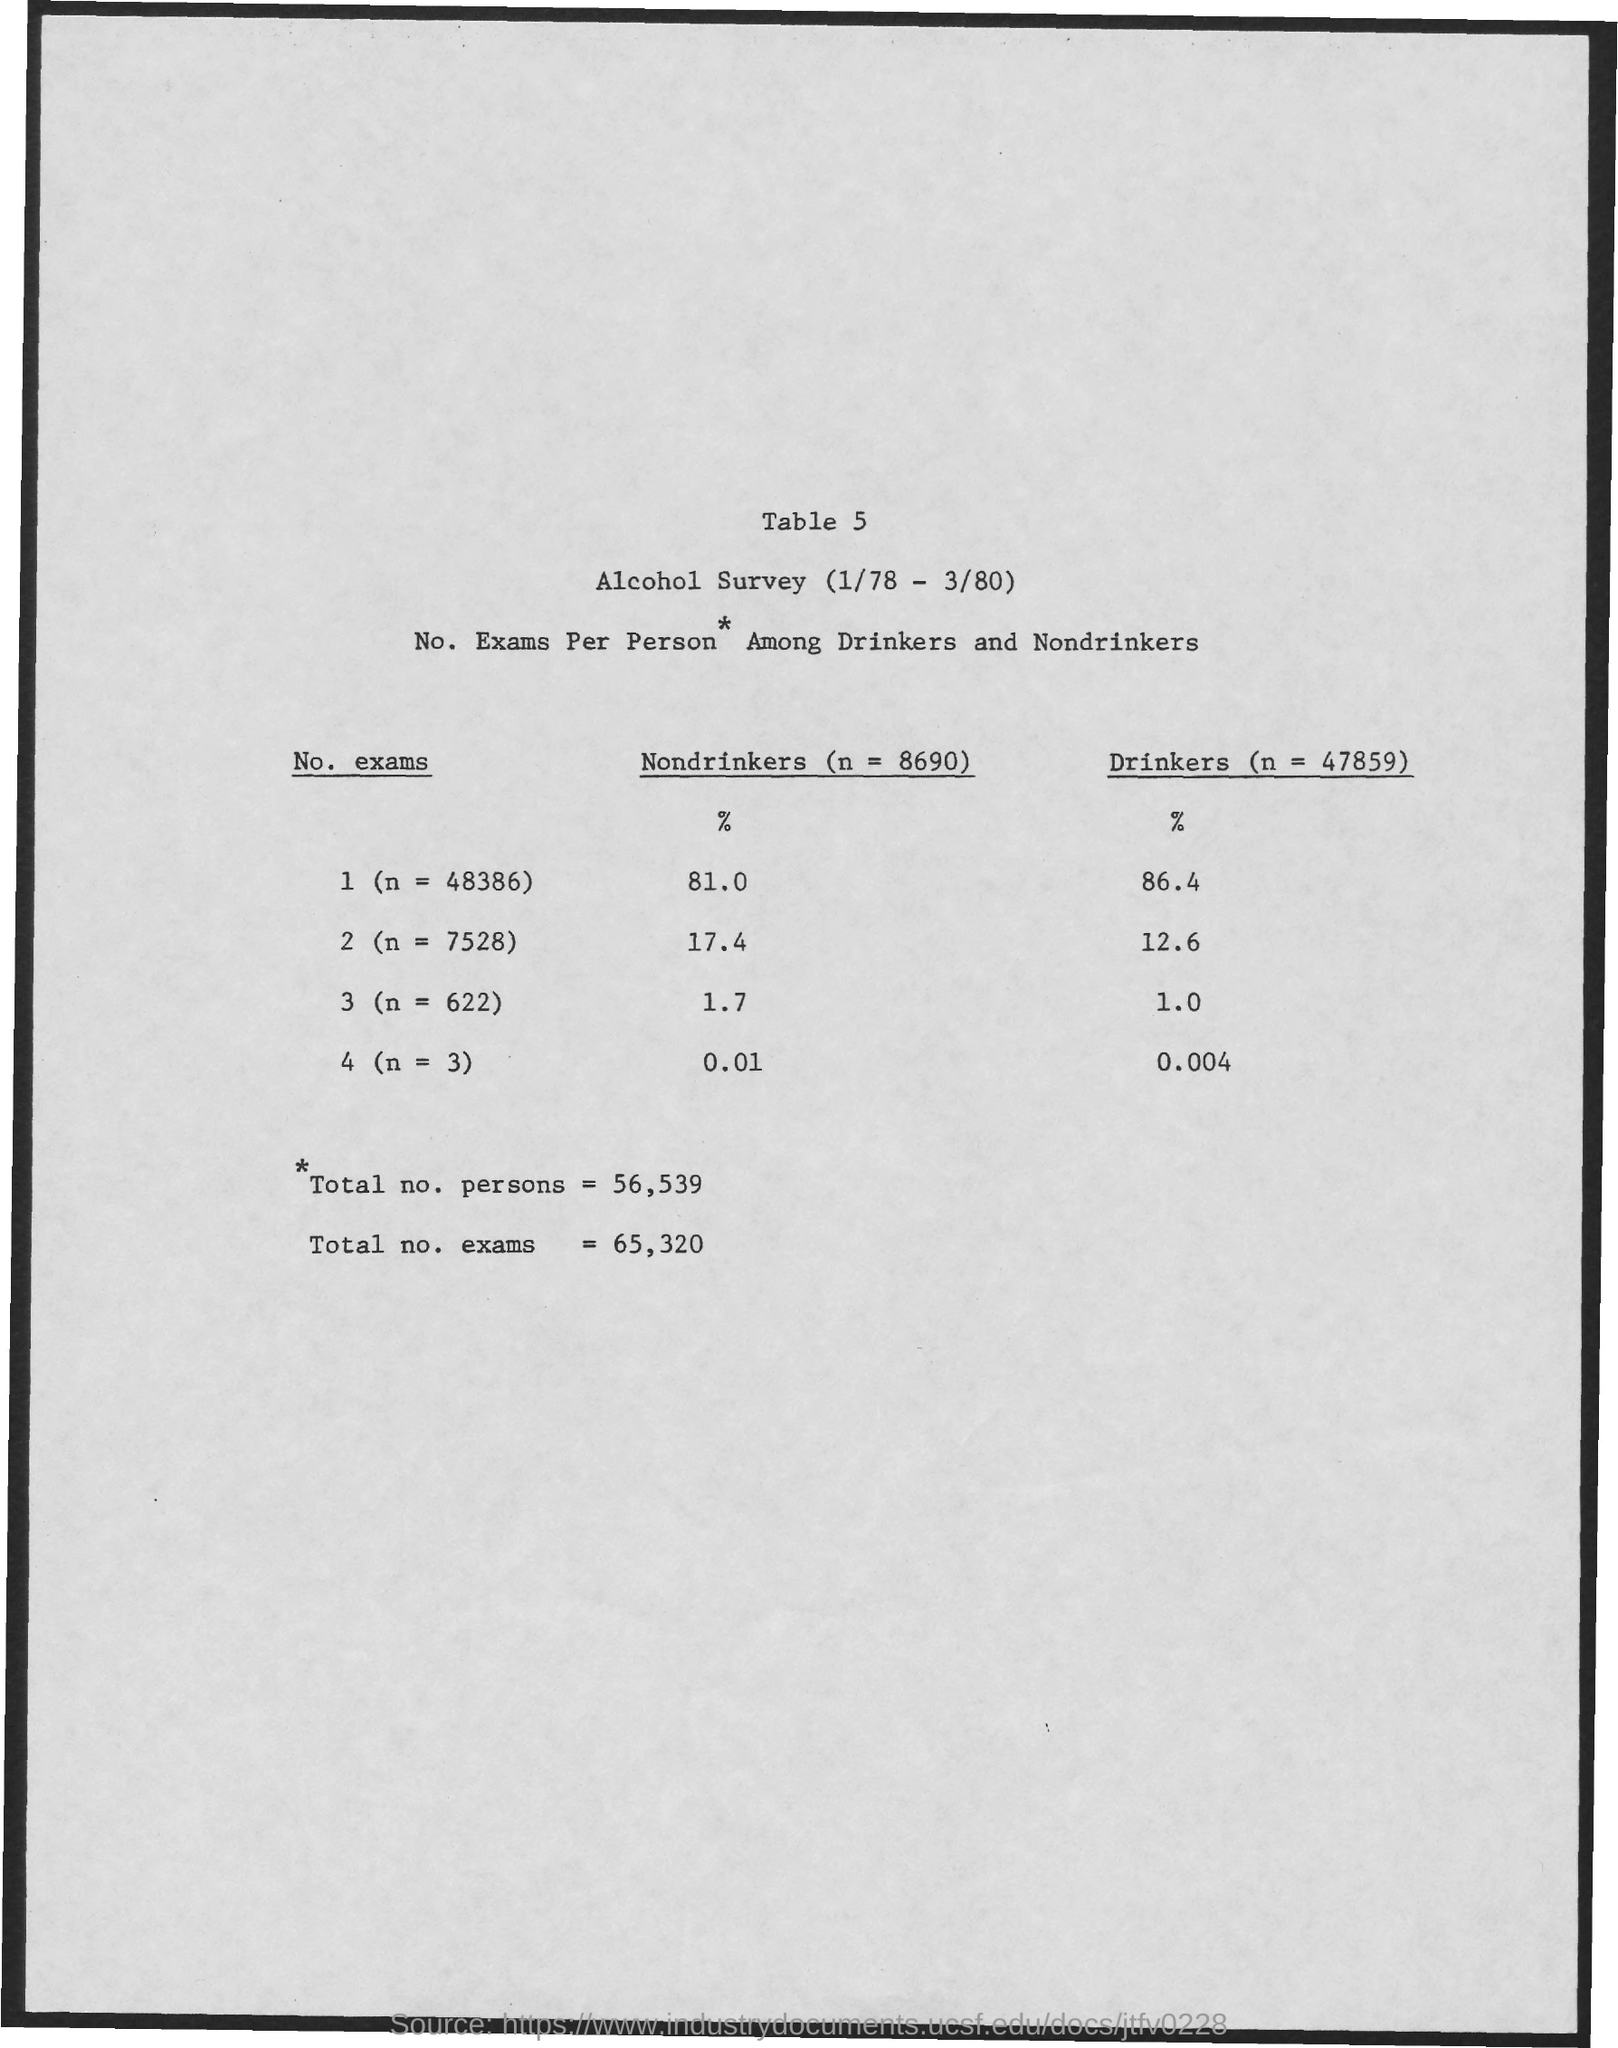Identify some key points in this picture. What is the table number? It is 5, as declared. In a sample of 48,386 individuals, 81% were nondrinkers. The percentage of drinkers for n=3 is approximately 0.004. The percentage of drinkers is lowest for the value of "n" that is 3. There have been a total of 65,320 exams. 